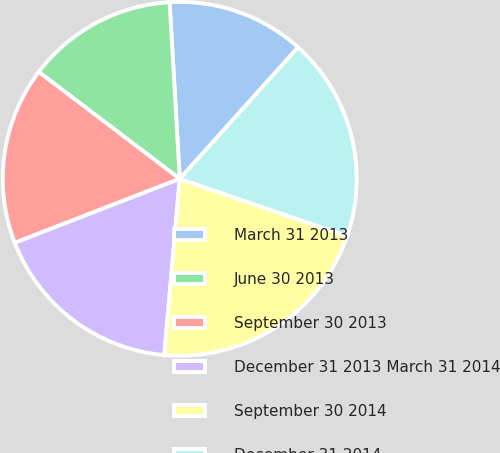Convert chart to OTSL. <chart><loc_0><loc_0><loc_500><loc_500><pie_chart><fcel>March 31 2013<fcel>June 30 2013<fcel>September 30 2013<fcel>December 31 2013 March 31 2014<fcel>September 30 2014<fcel>December 31 2014<nl><fcel>12.57%<fcel>13.76%<fcel>16.21%<fcel>17.72%<fcel>21.15%<fcel>18.58%<nl></chart> 